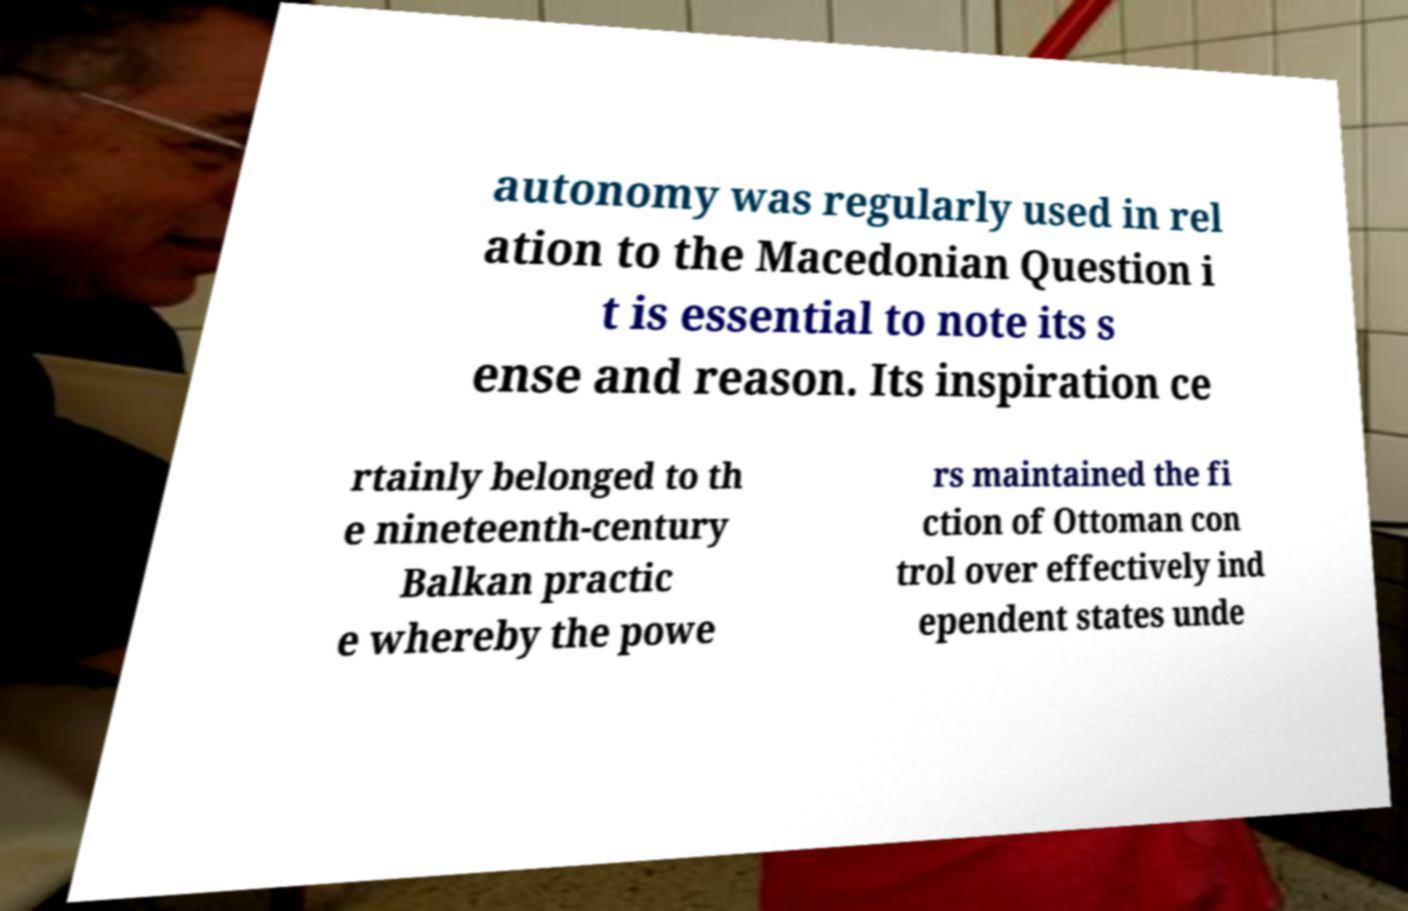Can you read and provide the text displayed in the image?This photo seems to have some interesting text. Can you extract and type it out for me? autonomy was regularly used in rel ation to the Macedonian Question i t is essential to note its s ense and reason. Its inspiration ce rtainly belonged to th e nineteenth-century Balkan practic e whereby the powe rs maintained the fi ction of Ottoman con trol over effectively ind ependent states unde 